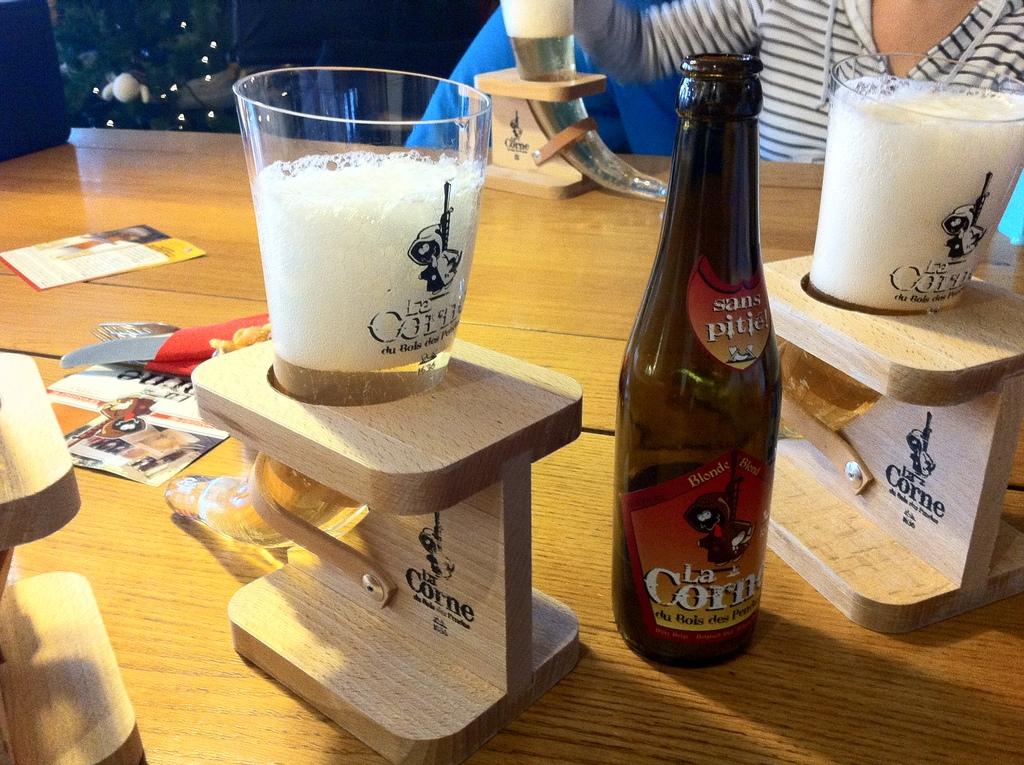What is the brand of the drink?
Your response must be concise. La corne. 